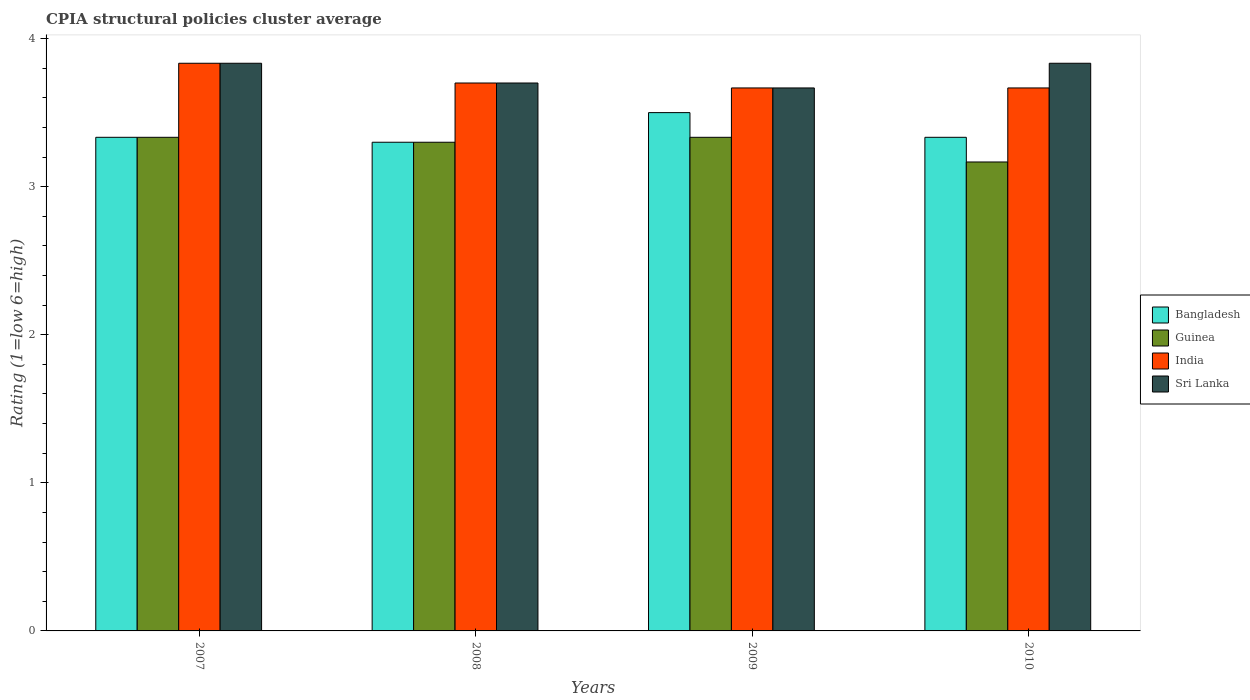How many groups of bars are there?
Provide a short and direct response. 4. Are the number of bars per tick equal to the number of legend labels?
Provide a succinct answer. Yes. Are the number of bars on each tick of the X-axis equal?
Your answer should be very brief. Yes. How many bars are there on the 1st tick from the right?
Your response must be concise. 4. In how many cases, is the number of bars for a given year not equal to the number of legend labels?
Make the answer very short. 0. What is the CPIA rating in India in 2008?
Provide a short and direct response. 3.7. Across all years, what is the maximum CPIA rating in Sri Lanka?
Keep it short and to the point. 3.83. Across all years, what is the minimum CPIA rating in Guinea?
Provide a short and direct response. 3.17. What is the total CPIA rating in India in the graph?
Your response must be concise. 14.87. What is the difference between the CPIA rating in India in 2008 and the CPIA rating in Guinea in 2010?
Offer a very short reply. 0.53. What is the average CPIA rating in Bangladesh per year?
Your answer should be very brief. 3.37. In the year 2008, what is the difference between the CPIA rating in Sri Lanka and CPIA rating in Bangladesh?
Provide a short and direct response. 0.4. What is the ratio of the CPIA rating in Bangladesh in 2007 to that in 2008?
Offer a terse response. 1.01. Is the CPIA rating in India in 2007 less than that in 2008?
Ensure brevity in your answer.  No. What is the difference between the highest and the second highest CPIA rating in Guinea?
Your answer should be compact. 0. What is the difference between the highest and the lowest CPIA rating in Sri Lanka?
Your response must be concise. 0.17. In how many years, is the CPIA rating in Sri Lanka greater than the average CPIA rating in Sri Lanka taken over all years?
Your response must be concise. 2. Is the sum of the CPIA rating in Bangladesh in 2007 and 2010 greater than the maximum CPIA rating in Guinea across all years?
Your answer should be compact. Yes. What does the 4th bar from the left in 2010 represents?
Your response must be concise. Sri Lanka. What does the 1st bar from the right in 2010 represents?
Ensure brevity in your answer.  Sri Lanka. Are all the bars in the graph horizontal?
Offer a very short reply. No. How many years are there in the graph?
Provide a succinct answer. 4. What is the difference between two consecutive major ticks on the Y-axis?
Provide a short and direct response. 1. Does the graph contain any zero values?
Your answer should be compact. No. Does the graph contain grids?
Ensure brevity in your answer.  No. Where does the legend appear in the graph?
Your response must be concise. Center right. What is the title of the graph?
Offer a terse response. CPIA structural policies cluster average. Does "Serbia" appear as one of the legend labels in the graph?
Offer a terse response. No. What is the label or title of the X-axis?
Offer a very short reply. Years. What is the Rating (1=low 6=high) in Bangladesh in 2007?
Offer a terse response. 3.33. What is the Rating (1=low 6=high) of Guinea in 2007?
Provide a short and direct response. 3.33. What is the Rating (1=low 6=high) of India in 2007?
Your answer should be compact. 3.83. What is the Rating (1=low 6=high) of Sri Lanka in 2007?
Make the answer very short. 3.83. What is the Rating (1=low 6=high) of Bangladesh in 2008?
Give a very brief answer. 3.3. What is the Rating (1=low 6=high) of India in 2008?
Your response must be concise. 3.7. What is the Rating (1=low 6=high) of Sri Lanka in 2008?
Offer a terse response. 3.7. What is the Rating (1=low 6=high) of Bangladesh in 2009?
Your response must be concise. 3.5. What is the Rating (1=low 6=high) in Guinea in 2009?
Ensure brevity in your answer.  3.33. What is the Rating (1=low 6=high) of India in 2009?
Keep it short and to the point. 3.67. What is the Rating (1=low 6=high) in Sri Lanka in 2009?
Keep it short and to the point. 3.67. What is the Rating (1=low 6=high) of Bangladesh in 2010?
Your answer should be very brief. 3.33. What is the Rating (1=low 6=high) of Guinea in 2010?
Provide a short and direct response. 3.17. What is the Rating (1=low 6=high) in India in 2010?
Your answer should be compact. 3.67. What is the Rating (1=low 6=high) of Sri Lanka in 2010?
Your answer should be compact. 3.83. Across all years, what is the maximum Rating (1=low 6=high) in Guinea?
Give a very brief answer. 3.33. Across all years, what is the maximum Rating (1=low 6=high) of India?
Offer a very short reply. 3.83. Across all years, what is the maximum Rating (1=low 6=high) of Sri Lanka?
Provide a short and direct response. 3.83. Across all years, what is the minimum Rating (1=low 6=high) in Bangladesh?
Ensure brevity in your answer.  3.3. Across all years, what is the minimum Rating (1=low 6=high) of Guinea?
Ensure brevity in your answer.  3.17. Across all years, what is the minimum Rating (1=low 6=high) of India?
Your answer should be compact. 3.67. Across all years, what is the minimum Rating (1=low 6=high) of Sri Lanka?
Make the answer very short. 3.67. What is the total Rating (1=low 6=high) in Bangladesh in the graph?
Make the answer very short. 13.47. What is the total Rating (1=low 6=high) in Guinea in the graph?
Keep it short and to the point. 13.13. What is the total Rating (1=low 6=high) in India in the graph?
Your answer should be compact. 14.87. What is the total Rating (1=low 6=high) of Sri Lanka in the graph?
Give a very brief answer. 15.03. What is the difference between the Rating (1=low 6=high) in Guinea in 2007 and that in 2008?
Provide a succinct answer. 0.03. What is the difference between the Rating (1=low 6=high) of India in 2007 and that in 2008?
Provide a short and direct response. 0.13. What is the difference between the Rating (1=low 6=high) of Sri Lanka in 2007 and that in 2008?
Keep it short and to the point. 0.13. What is the difference between the Rating (1=low 6=high) in Bangladesh in 2007 and that in 2009?
Provide a short and direct response. -0.17. What is the difference between the Rating (1=low 6=high) of Bangladesh in 2007 and that in 2010?
Keep it short and to the point. 0. What is the difference between the Rating (1=low 6=high) in Guinea in 2007 and that in 2010?
Your response must be concise. 0.17. What is the difference between the Rating (1=low 6=high) of Sri Lanka in 2007 and that in 2010?
Your response must be concise. 0. What is the difference between the Rating (1=low 6=high) of Guinea in 2008 and that in 2009?
Make the answer very short. -0.03. What is the difference between the Rating (1=low 6=high) in India in 2008 and that in 2009?
Keep it short and to the point. 0.03. What is the difference between the Rating (1=low 6=high) of Sri Lanka in 2008 and that in 2009?
Provide a short and direct response. 0.03. What is the difference between the Rating (1=low 6=high) of Bangladesh in 2008 and that in 2010?
Offer a terse response. -0.03. What is the difference between the Rating (1=low 6=high) of Guinea in 2008 and that in 2010?
Make the answer very short. 0.13. What is the difference between the Rating (1=low 6=high) in Sri Lanka in 2008 and that in 2010?
Offer a very short reply. -0.13. What is the difference between the Rating (1=low 6=high) in Guinea in 2009 and that in 2010?
Provide a short and direct response. 0.17. What is the difference between the Rating (1=low 6=high) of Sri Lanka in 2009 and that in 2010?
Offer a terse response. -0.17. What is the difference between the Rating (1=low 6=high) of Bangladesh in 2007 and the Rating (1=low 6=high) of India in 2008?
Your answer should be compact. -0.37. What is the difference between the Rating (1=low 6=high) in Bangladesh in 2007 and the Rating (1=low 6=high) in Sri Lanka in 2008?
Provide a succinct answer. -0.37. What is the difference between the Rating (1=low 6=high) in Guinea in 2007 and the Rating (1=low 6=high) in India in 2008?
Ensure brevity in your answer.  -0.37. What is the difference between the Rating (1=low 6=high) of Guinea in 2007 and the Rating (1=low 6=high) of Sri Lanka in 2008?
Offer a terse response. -0.37. What is the difference between the Rating (1=low 6=high) of India in 2007 and the Rating (1=low 6=high) of Sri Lanka in 2008?
Your answer should be compact. 0.13. What is the difference between the Rating (1=low 6=high) in Bangladesh in 2007 and the Rating (1=low 6=high) in Guinea in 2009?
Ensure brevity in your answer.  0. What is the difference between the Rating (1=low 6=high) of Bangladesh in 2007 and the Rating (1=low 6=high) of India in 2009?
Your answer should be compact. -0.33. What is the difference between the Rating (1=low 6=high) of Guinea in 2007 and the Rating (1=low 6=high) of India in 2009?
Your response must be concise. -0.33. What is the difference between the Rating (1=low 6=high) of Bangladesh in 2007 and the Rating (1=low 6=high) of Sri Lanka in 2010?
Your response must be concise. -0.5. What is the difference between the Rating (1=low 6=high) of Guinea in 2007 and the Rating (1=low 6=high) of Sri Lanka in 2010?
Offer a terse response. -0.5. What is the difference between the Rating (1=low 6=high) in Bangladesh in 2008 and the Rating (1=low 6=high) in Guinea in 2009?
Make the answer very short. -0.03. What is the difference between the Rating (1=low 6=high) in Bangladesh in 2008 and the Rating (1=low 6=high) in India in 2009?
Give a very brief answer. -0.37. What is the difference between the Rating (1=low 6=high) of Bangladesh in 2008 and the Rating (1=low 6=high) of Sri Lanka in 2009?
Make the answer very short. -0.37. What is the difference between the Rating (1=low 6=high) in Guinea in 2008 and the Rating (1=low 6=high) in India in 2009?
Your answer should be very brief. -0.37. What is the difference between the Rating (1=low 6=high) of Guinea in 2008 and the Rating (1=low 6=high) of Sri Lanka in 2009?
Offer a very short reply. -0.37. What is the difference between the Rating (1=low 6=high) of Bangladesh in 2008 and the Rating (1=low 6=high) of Guinea in 2010?
Make the answer very short. 0.13. What is the difference between the Rating (1=low 6=high) in Bangladesh in 2008 and the Rating (1=low 6=high) in India in 2010?
Your answer should be compact. -0.37. What is the difference between the Rating (1=low 6=high) of Bangladesh in 2008 and the Rating (1=low 6=high) of Sri Lanka in 2010?
Your answer should be compact. -0.53. What is the difference between the Rating (1=low 6=high) in Guinea in 2008 and the Rating (1=low 6=high) in India in 2010?
Provide a succinct answer. -0.37. What is the difference between the Rating (1=low 6=high) in Guinea in 2008 and the Rating (1=low 6=high) in Sri Lanka in 2010?
Give a very brief answer. -0.53. What is the difference between the Rating (1=low 6=high) in India in 2008 and the Rating (1=low 6=high) in Sri Lanka in 2010?
Your response must be concise. -0.13. What is the difference between the Rating (1=low 6=high) in Bangladesh in 2009 and the Rating (1=low 6=high) in Guinea in 2010?
Give a very brief answer. 0.33. What is the difference between the Rating (1=low 6=high) in Bangladesh in 2009 and the Rating (1=low 6=high) in India in 2010?
Provide a short and direct response. -0.17. What is the difference between the Rating (1=low 6=high) in Bangladesh in 2009 and the Rating (1=low 6=high) in Sri Lanka in 2010?
Your answer should be very brief. -0.33. What is the difference between the Rating (1=low 6=high) of Guinea in 2009 and the Rating (1=low 6=high) of India in 2010?
Your answer should be compact. -0.33. What is the difference between the Rating (1=low 6=high) of India in 2009 and the Rating (1=low 6=high) of Sri Lanka in 2010?
Keep it short and to the point. -0.17. What is the average Rating (1=low 6=high) in Bangladesh per year?
Your response must be concise. 3.37. What is the average Rating (1=low 6=high) of Guinea per year?
Keep it short and to the point. 3.28. What is the average Rating (1=low 6=high) of India per year?
Provide a succinct answer. 3.72. What is the average Rating (1=low 6=high) in Sri Lanka per year?
Ensure brevity in your answer.  3.76. In the year 2007, what is the difference between the Rating (1=low 6=high) of Bangladesh and Rating (1=low 6=high) of Guinea?
Offer a very short reply. 0. In the year 2007, what is the difference between the Rating (1=low 6=high) of Bangladesh and Rating (1=low 6=high) of India?
Your answer should be very brief. -0.5. In the year 2007, what is the difference between the Rating (1=low 6=high) in Bangladesh and Rating (1=low 6=high) in Sri Lanka?
Your answer should be very brief. -0.5. In the year 2007, what is the difference between the Rating (1=low 6=high) of Guinea and Rating (1=low 6=high) of India?
Your response must be concise. -0.5. In the year 2008, what is the difference between the Rating (1=low 6=high) of Bangladesh and Rating (1=low 6=high) of Guinea?
Give a very brief answer. 0. In the year 2008, what is the difference between the Rating (1=low 6=high) in Guinea and Rating (1=low 6=high) in Sri Lanka?
Offer a terse response. -0.4. In the year 2008, what is the difference between the Rating (1=low 6=high) in India and Rating (1=low 6=high) in Sri Lanka?
Your answer should be very brief. 0. In the year 2009, what is the difference between the Rating (1=low 6=high) of Bangladesh and Rating (1=low 6=high) of Sri Lanka?
Give a very brief answer. -0.17. In the year 2010, what is the difference between the Rating (1=low 6=high) in Bangladesh and Rating (1=low 6=high) in Sri Lanka?
Offer a very short reply. -0.5. In the year 2010, what is the difference between the Rating (1=low 6=high) of Guinea and Rating (1=low 6=high) of Sri Lanka?
Give a very brief answer. -0.67. What is the ratio of the Rating (1=low 6=high) of Guinea in 2007 to that in 2008?
Offer a very short reply. 1.01. What is the ratio of the Rating (1=low 6=high) in India in 2007 to that in 2008?
Keep it short and to the point. 1.04. What is the ratio of the Rating (1=low 6=high) in Sri Lanka in 2007 to that in 2008?
Make the answer very short. 1.04. What is the ratio of the Rating (1=low 6=high) of Bangladesh in 2007 to that in 2009?
Make the answer very short. 0.95. What is the ratio of the Rating (1=low 6=high) in Guinea in 2007 to that in 2009?
Make the answer very short. 1. What is the ratio of the Rating (1=low 6=high) in India in 2007 to that in 2009?
Give a very brief answer. 1.05. What is the ratio of the Rating (1=low 6=high) in Sri Lanka in 2007 to that in 2009?
Ensure brevity in your answer.  1.05. What is the ratio of the Rating (1=low 6=high) of Bangladesh in 2007 to that in 2010?
Offer a terse response. 1. What is the ratio of the Rating (1=low 6=high) of Guinea in 2007 to that in 2010?
Your answer should be compact. 1.05. What is the ratio of the Rating (1=low 6=high) of India in 2007 to that in 2010?
Provide a succinct answer. 1.05. What is the ratio of the Rating (1=low 6=high) in Bangladesh in 2008 to that in 2009?
Provide a succinct answer. 0.94. What is the ratio of the Rating (1=low 6=high) of Guinea in 2008 to that in 2009?
Keep it short and to the point. 0.99. What is the ratio of the Rating (1=low 6=high) in India in 2008 to that in 2009?
Give a very brief answer. 1.01. What is the ratio of the Rating (1=low 6=high) in Sri Lanka in 2008 to that in 2009?
Offer a very short reply. 1.01. What is the ratio of the Rating (1=low 6=high) in Guinea in 2008 to that in 2010?
Give a very brief answer. 1.04. What is the ratio of the Rating (1=low 6=high) in India in 2008 to that in 2010?
Ensure brevity in your answer.  1.01. What is the ratio of the Rating (1=low 6=high) of Sri Lanka in 2008 to that in 2010?
Offer a terse response. 0.97. What is the ratio of the Rating (1=low 6=high) of Guinea in 2009 to that in 2010?
Provide a succinct answer. 1.05. What is the ratio of the Rating (1=low 6=high) of Sri Lanka in 2009 to that in 2010?
Provide a succinct answer. 0.96. What is the difference between the highest and the second highest Rating (1=low 6=high) in India?
Offer a terse response. 0.13. What is the difference between the highest and the lowest Rating (1=low 6=high) of India?
Ensure brevity in your answer.  0.17. What is the difference between the highest and the lowest Rating (1=low 6=high) of Sri Lanka?
Provide a short and direct response. 0.17. 